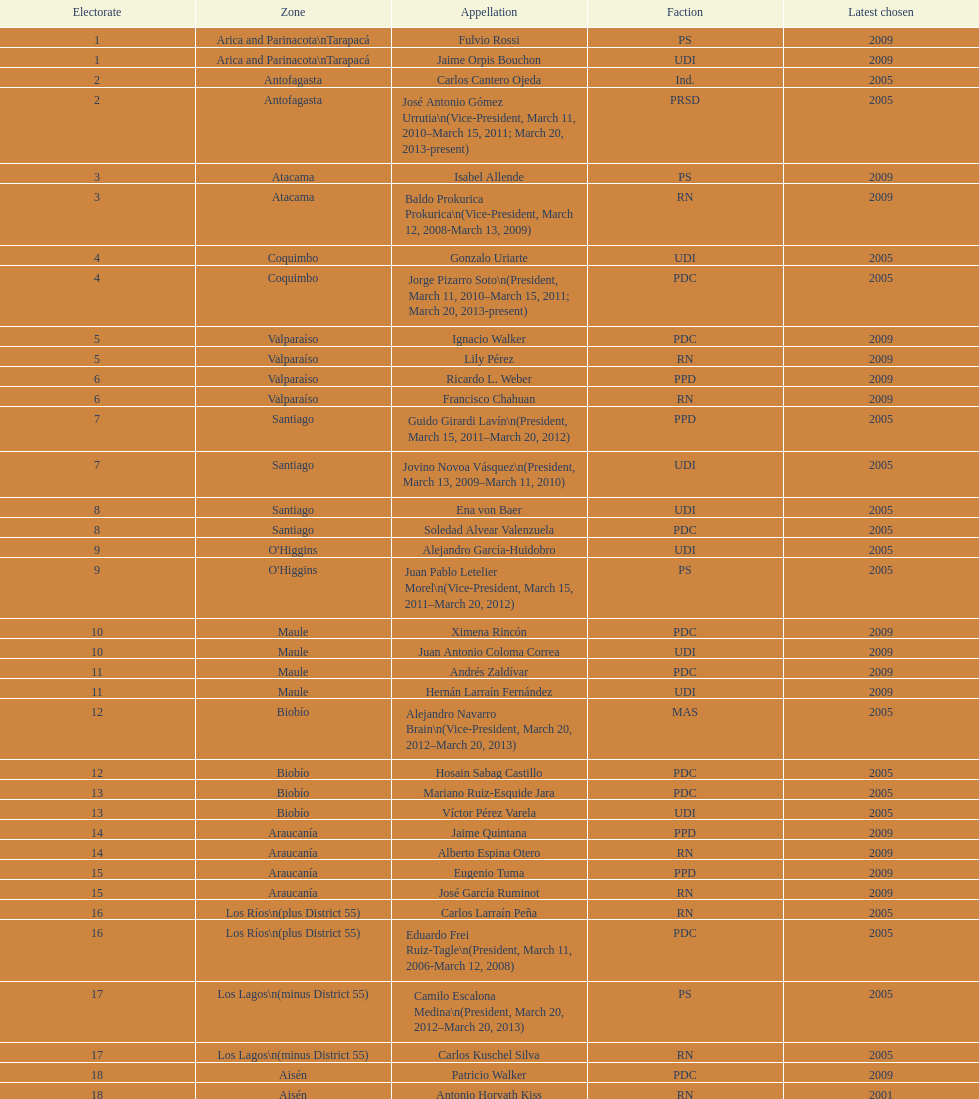How long was baldo prokurica prokurica vice-president? 1 year. 